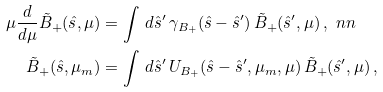<formula> <loc_0><loc_0><loc_500><loc_500>\mu \frac { d } { d \mu } \tilde { B } _ { + } ( \hat { s } , \mu ) & = \int \, d \hat { s } ^ { \prime } \, \gamma _ { B _ { + } } ( \hat { s } - \hat { s } ^ { \prime } ) \, \tilde { B } _ { + } ( \hat { s } ^ { \prime } , \mu ) \, , \ n n \\ \tilde { B } _ { + } ( \hat { s } , \mu _ { m } ) & = \int \, d \hat { s } ^ { \prime } \, U _ { B _ { + } } ( \hat { s } - \hat { s } ^ { \prime } , \mu _ { m } , \mu ) \, \tilde { B } _ { + } ( \hat { s } ^ { \prime } , \mu ) \, ,</formula> 